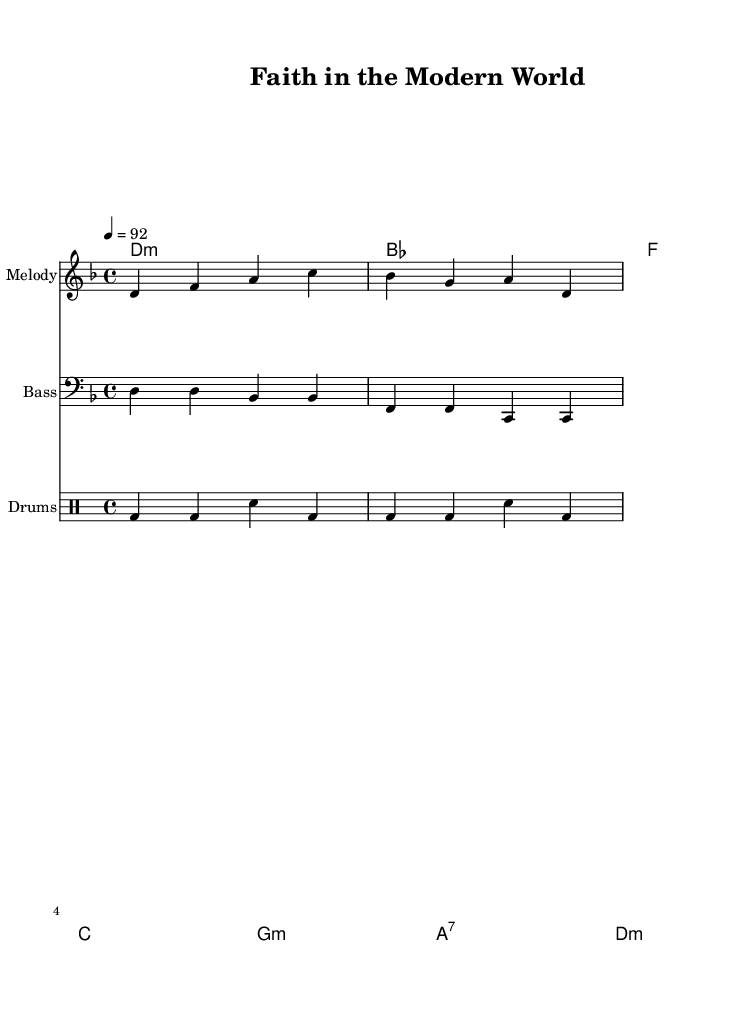What is the key signature of this music? The key signature indicated at the beginning of the score shows that the music is in D minor, which has one flat (B flat).
Answer: D minor What is the time signature of this piece? The time signature shown at the start is 4/4, meaning there are four beats per measure.
Answer: 4/4 What is the tempo marking of this composition? The tempo marking states "4 = 92", indicating that there are 92 beats per minute occurring at quarter note=92.
Answer: 92 What is the primary chord of the first bar? The first bar shows the chord symbol "d1:m" which represents the D minor chord; this is the primary chord used in the melody.
Answer: D minor How many measures are there in total? By counting the number of chord symbols, we identify there are a total of 8 measures in the piece.
Answer: 8 What type of drums are indicated in the score? The score is labeled with "DrumStaff," and within it, the notation specifies "bd" for bass drum and "sn" for snare drum, which are standard in hip hop music.
Answer: Bass drum and snare drum What is the significance of the melody's intervals? The melody starts with a sequence of notes that create an ascending pattern, which is common in hip hop to emphasize themes of hope or elevation, reflecting faith's role in modern society.
Answer: Ascending pattern 